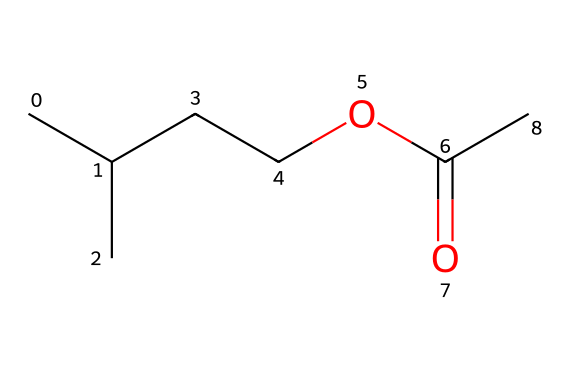How many carbon atoms are in isoamyl acetate? The SMILES representation shows CC(C)CCOC(=O)C, where "C" denotes carbon atoms. Counting the "C" entities, there are 5 carbon atoms from the "CC(C)CC" part and 1 from the "C" at the end, totaling 6.
Answer: six What functional group is present in isoamyl acetate? In the SMILES, the "COC(=O)" part indicates the presence of an ester functional group, characterized by the carbonyl (C=O) and ether (C-O) arrangements.
Answer: ester What is the molecular formula of isoamyl acetate? To find the molecular formula, identify the number of each type of atom from the SMILES representation. There are 6 carbon, 12 hydrogen, and 2 oxygen atoms, leading to the formula C5H10O2.
Answer: C5H10O2 Which part of the structure contributes to the fruity aroma? The ester functional group (as seen in the "COC(=O)") is known for imparting fruity aromas. Specifically, the carbon chain and the arrangement of atoms contribute to the particular scent, which is recognized as banana-like.
Answer: ester group How many oxygen atoms are contained in isoamyl acetate? The SMILES representation clearly includes two "O" symbols, indicating there are 2 oxygen atoms in the structure.
Answer: two What is the relationship between isoamyl acetate and the banana flavor? Isoamyl acetate is responsible for the artificial banana flavor, due to the unique structure of the ester which mimics the natural aroma compounds found in ripe bananas.
Answer: flavor compound Is isoamyl acetate a saturated or unsaturated ester? The structure shows that all carbon atoms are bonded to the maximum number of hydrogens (single bonds), indicating it is saturated.
Answer: saturated 